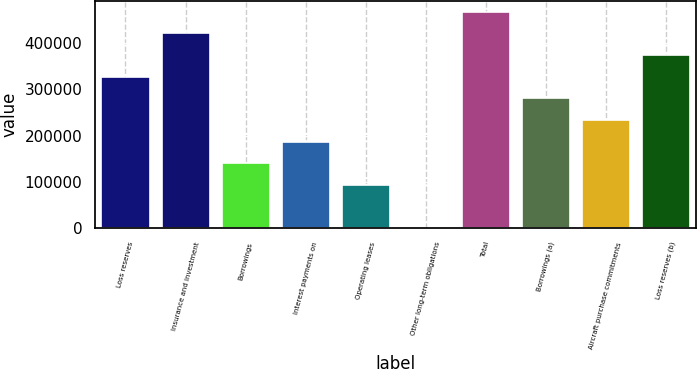Convert chart to OTSL. <chart><loc_0><loc_0><loc_500><loc_500><bar_chart><fcel>Loss reserves<fcel>Insurance and investment<fcel>Borrowings<fcel>Interest payments on<fcel>Operating leases<fcel>Other long-term obligations<fcel>Total<fcel>Borrowings (a)<fcel>Aircraft purchase commitments<fcel>Loss reserves (b)<nl><fcel>327624<fcel>421220<fcel>140431<fcel>187229<fcel>93633.2<fcel>37<fcel>468018<fcel>280826<fcel>234028<fcel>374422<nl></chart> 